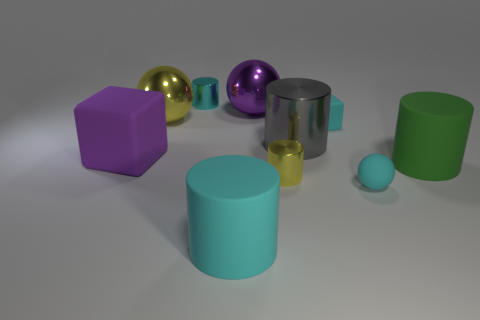Subtract all yellow cylinders. How many cylinders are left? 4 Subtract all big green rubber cylinders. How many cylinders are left? 4 Subtract all purple cylinders. Subtract all yellow cubes. How many cylinders are left? 5 Subtract all blocks. How many objects are left? 8 Add 9 large purple metal spheres. How many large purple metal spheres exist? 10 Subtract 0 green blocks. How many objects are left? 10 Subtract all tiny green rubber cylinders. Subtract all tiny cubes. How many objects are left? 9 Add 7 tiny yellow shiny cylinders. How many tiny yellow shiny cylinders are left? 8 